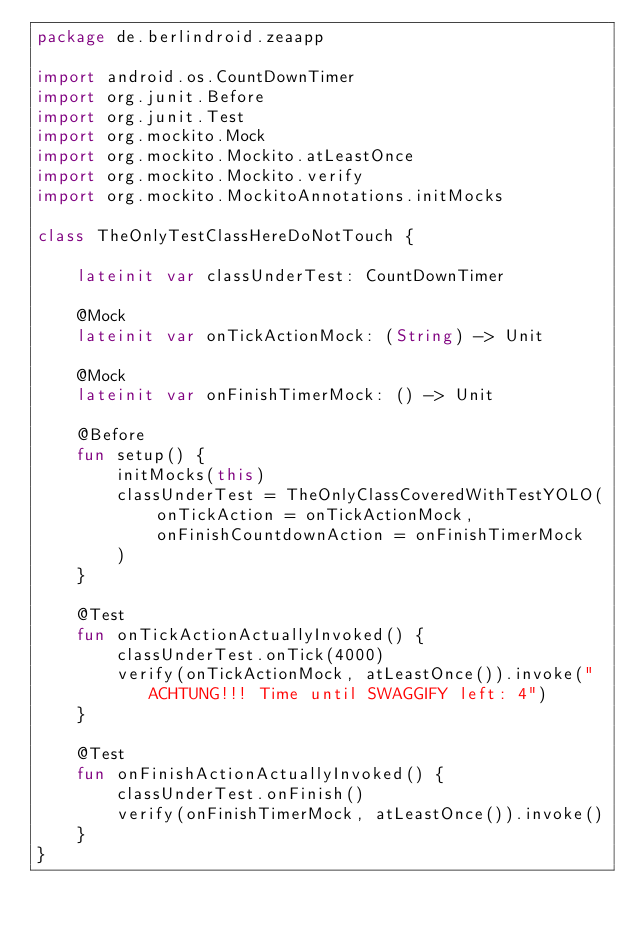<code> <loc_0><loc_0><loc_500><loc_500><_Kotlin_>package de.berlindroid.zeaapp

import android.os.CountDownTimer
import org.junit.Before
import org.junit.Test
import org.mockito.Mock
import org.mockito.Mockito.atLeastOnce
import org.mockito.Mockito.verify
import org.mockito.MockitoAnnotations.initMocks

class TheOnlyTestClassHereDoNotTouch {

    lateinit var classUnderTest: CountDownTimer

    @Mock
    lateinit var onTickActionMock: (String) -> Unit

    @Mock
    lateinit var onFinishTimerMock: () -> Unit

    @Before
    fun setup() {
        initMocks(this)
        classUnderTest = TheOnlyClassCoveredWithTestYOLO(
            onTickAction = onTickActionMock,
            onFinishCountdownAction = onFinishTimerMock
        )
    }

    @Test
    fun onTickActionActuallyInvoked() {
        classUnderTest.onTick(4000)
        verify(onTickActionMock, atLeastOnce()).invoke("ACHTUNG!!! Time until SWAGGIFY left: 4")
    }

    @Test
    fun onFinishActionActuallyInvoked() {
        classUnderTest.onFinish()
        verify(onFinishTimerMock, atLeastOnce()).invoke()
    }
}</code> 